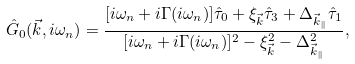Convert formula to latex. <formula><loc_0><loc_0><loc_500><loc_500>\hat { G } _ { 0 } ( \vec { k } , i \omega _ { n } ) = \frac { [ i \omega _ { n } + i \Gamma ( i \omega _ { n } ) ] \hat { \tau } _ { 0 } + \xi _ { \vec { k } } \hat { \tau } _ { 3 } + \Delta _ { \vec { k } _ { \| } } \hat { \tau } _ { 1 } } { [ i \omega _ { n } + i \Gamma ( i \omega _ { n } ) ] ^ { 2 } - \xi _ { \vec { k } } ^ { 2 } - \Delta _ { \vec { k } _ { \| } } ^ { 2 } } ,</formula> 